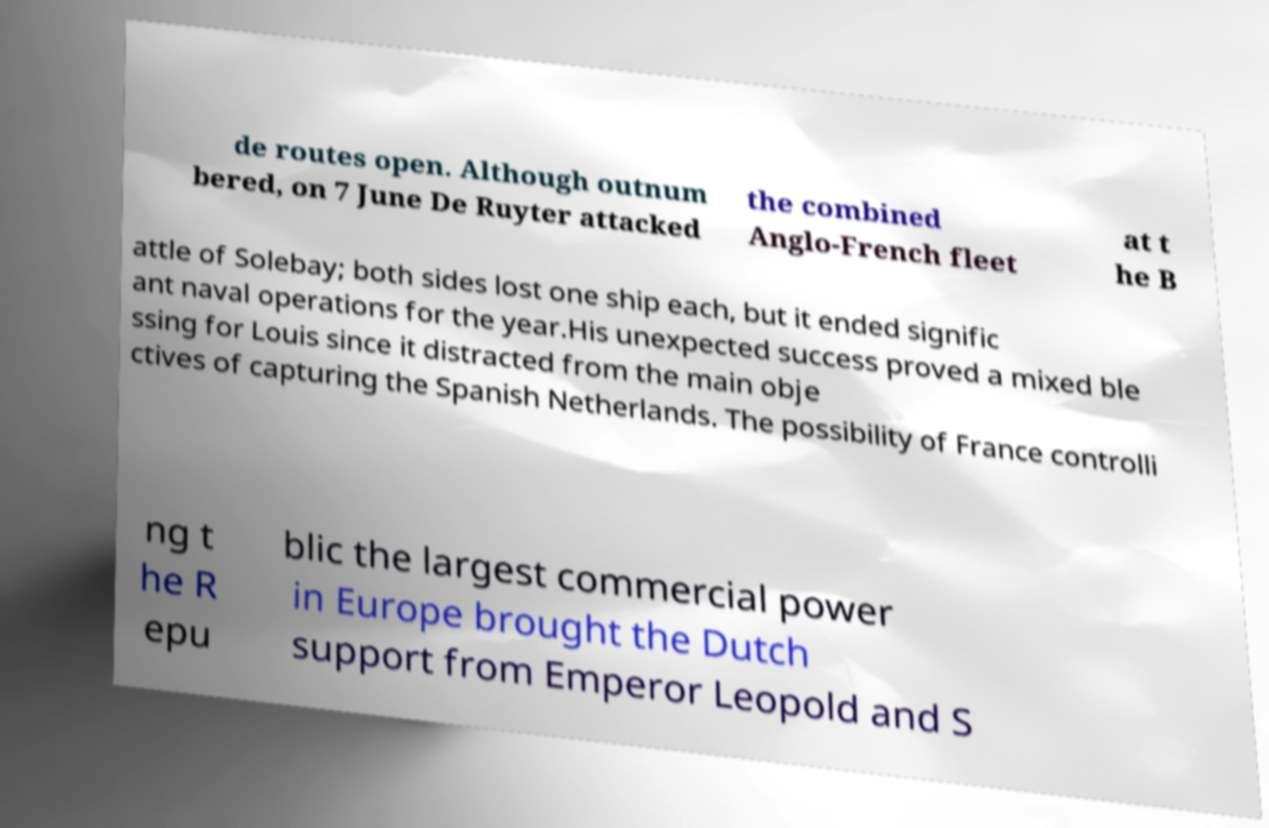Please identify and transcribe the text found in this image. de routes open. Although outnum bered, on 7 June De Ruyter attacked the combined Anglo-French fleet at t he B attle of Solebay; both sides lost one ship each, but it ended signific ant naval operations for the year.His unexpected success proved a mixed ble ssing for Louis since it distracted from the main obje ctives of capturing the Spanish Netherlands. The possibility of France controlli ng t he R epu blic the largest commercial power in Europe brought the Dutch support from Emperor Leopold and S 